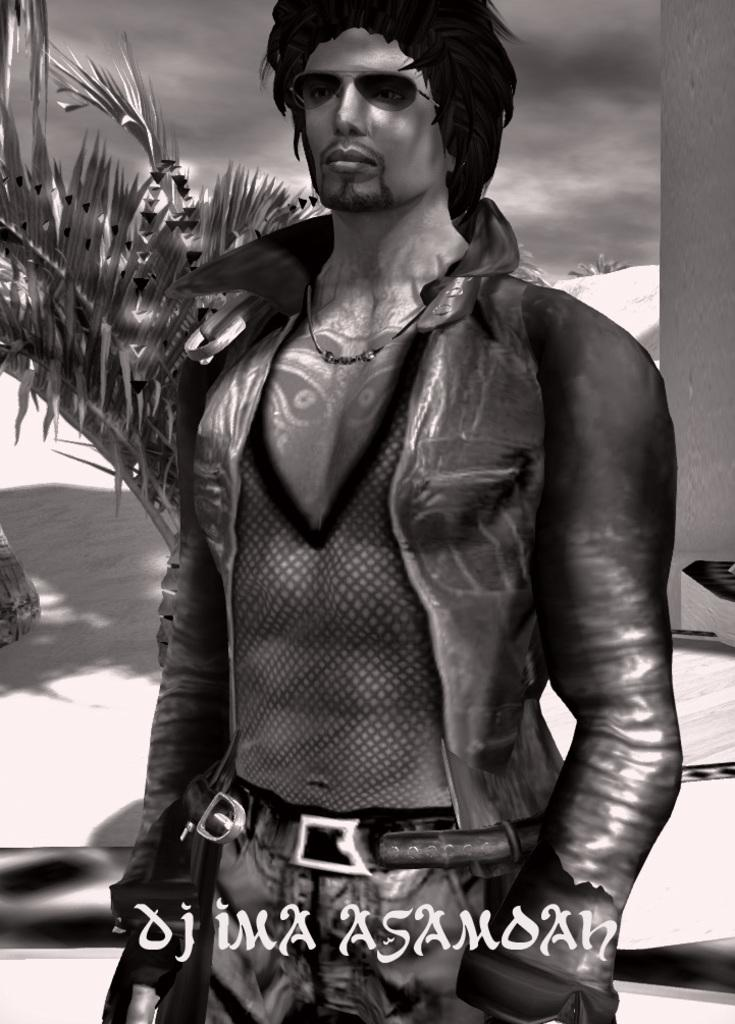What is the color scheme of the image? The image is black and white. Who or what can be seen in the image? There is a depiction of a man in the image. What type of natural environment is visible in the image? There are trees and snow in the image. What is visible in the background of the image? The sky is visible in the image. Is there any text present in the image? Yes, there is text at the bottom of the image. What type of comb is being used by the man in the image? There is no comb visible in the image; the man is not using any comb. How many cubs are present in the image? There are no cubs present in the image. 